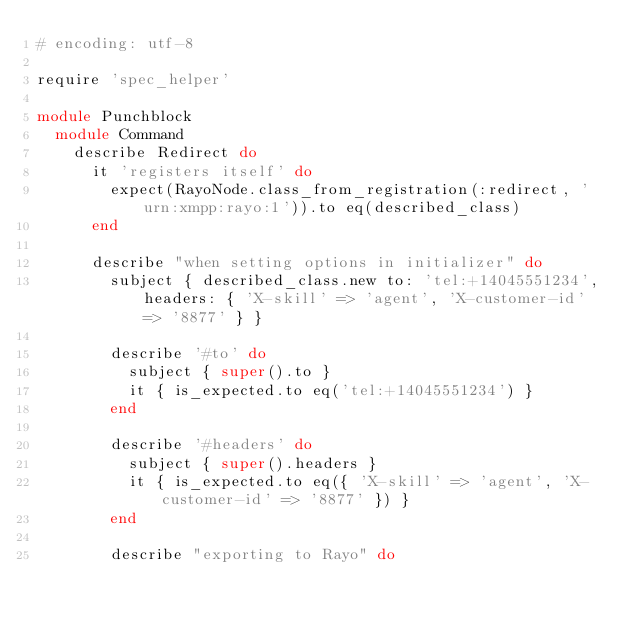<code> <loc_0><loc_0><loc_500><loc_500><_Ruby_># encoding: utf-8

require 'spec_helper'

module Punchblock
  module Command
    describe Redirect do
      it 'registers itself' do
        expect(RayoNode.class_from_registration(:redirect, 'urn:xmpp:rayo:1')).to eq(described_class)
      end

      describe "when setting options in initializer" do
        subject { described_class.new to: 'tel:+14045551234', headers: { 'X-skill' => 'agent', 'X-customer-id' => '8877' } }

        describe '#to' do
          subject { super().to }
          it { is_expected.to eq('tel:+14045551234') }
        end

        describe '#headers' do
          subject { super().headers }
          it { is_expected.to eq({ 'X-skill' => 'agent', 'X-customer-id' => '8877' }) }
        end

        describe "exporting to Rayo" do</code> 